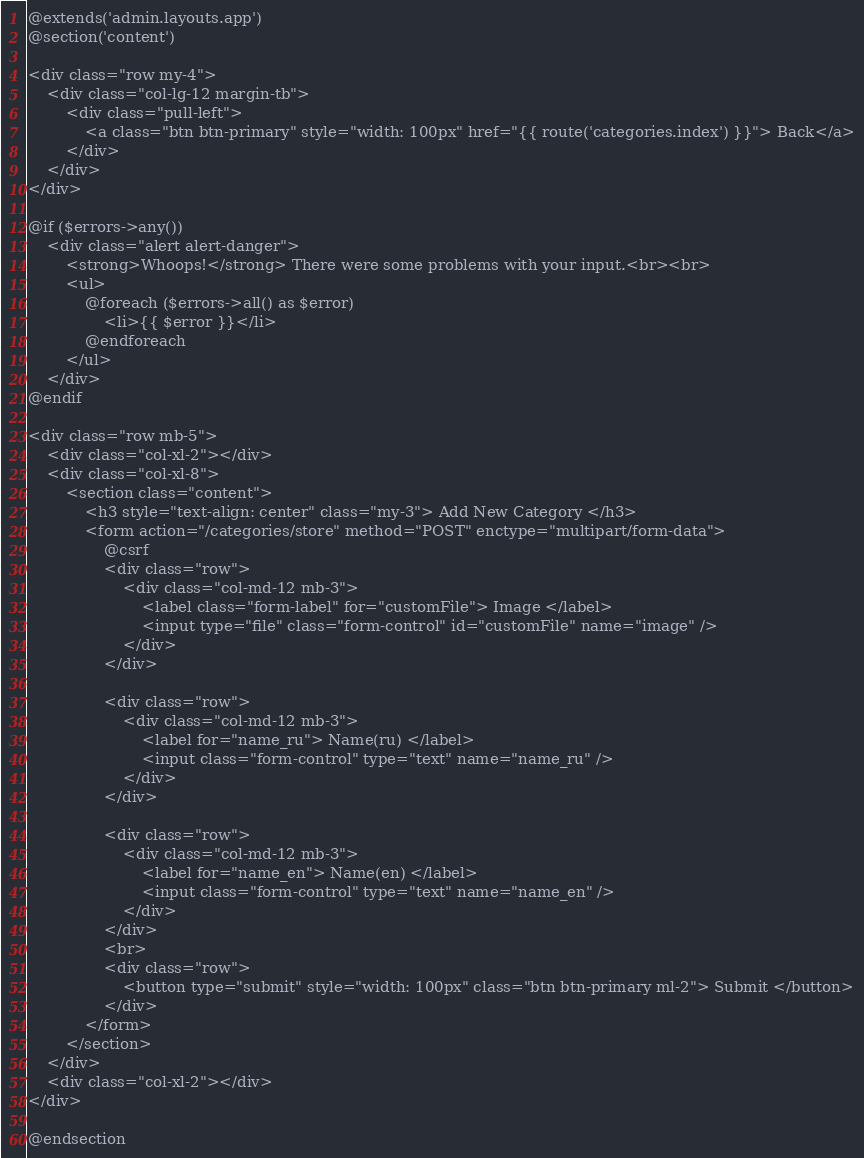<code> <loc_0><loc_0><loc_500><loc_500><_PHP_>@extends('admin.layouts.app')
@section('content')

<div class="row my-4">
    <div class="col-lg-12 margin-tb">
        <div class="pull-left">
            <a class="btn btn-primary" style="width: 100px" href="{{ route('categories.index') }}"> Back</a>
        </div>
    </div>
</div>

@if ($errors->any())
    <div class="alert alert-danger">
        <strong>Whoops!</strong> There were some problems with your input.<br><br>
        <ul>
            @foreach ($errors->all() as $error)
                <li>{{ $error }}</li>
            @endforeach
        </ul>
    </div>
@endif

<div class="row mb-5">
    <div class="col-xl-2"></div>
    <div class="col-xl-8">
        <section class="content">
            <h3 style="text-align: center" class="my-3"> Add New Category </h3>
            <form action="/categories/store" method="POST" enctype="multipart/form-data">
                @csrf
                <div class="row">
                    <div class="col-md-12 mb-3">
                        <label class="form-label" for="customFile"> Image </label>
                        <input type="file" class="form-control" id="customFile" name="image" />
                    </div>
                </div>

                <div class="row">
                    <div class="col-md-12 mb-3">
                        <label for="name_ru"> Name(ru) </label>
                        <input class="form-control" type="text" name="name_ru" />
                    </div>
                </div>

                <div class="row">
                    <div class="col-md-12 mb-3">
                        <label for="name_en"> Name(en) </label>
                        <input class="form-control" type="text" name="name_en" />
                    </div>
                </div>
                <br>
                <div class="row">
                    <button type="submit" style="width: 100px" class="btn btn-primary ml-2"> Submit </button>
                </div>
            </form>
        </section>
    </div>
    <div class="col-xl-2"></div>
</div>

@endsection
</code> 